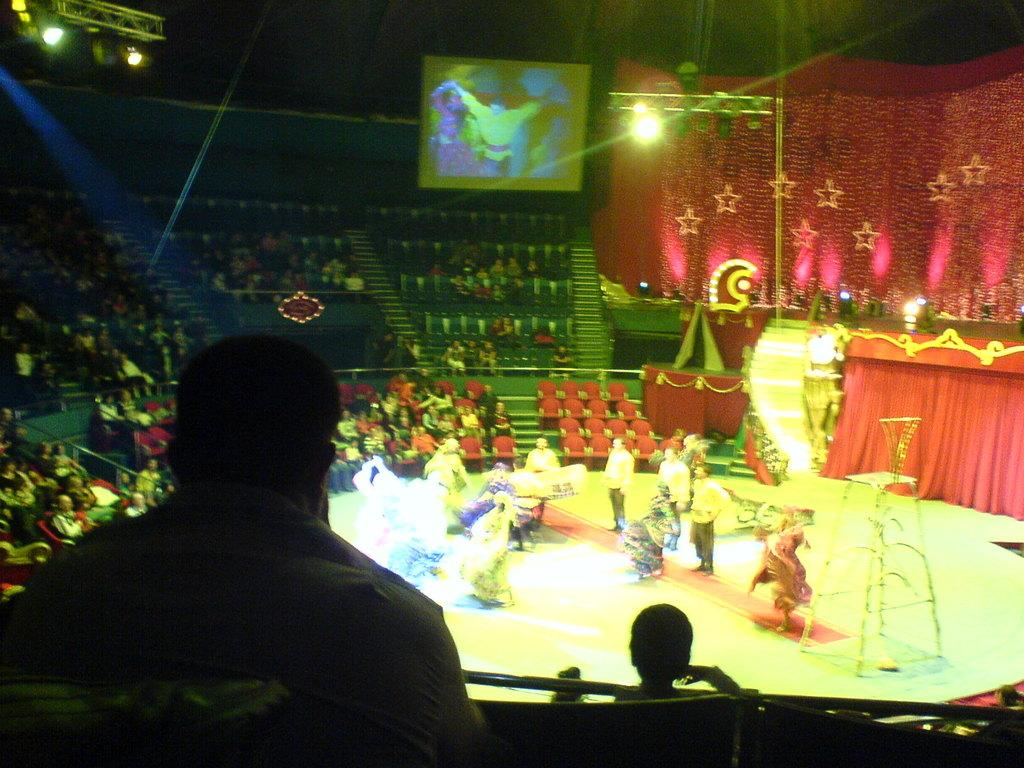How many people are in the image? There is a group of people in the image. What are some of the people in the image doing? Some people are sitting on chairs, while others are on stage. What can be seen in the background of the image? There is a screen, lights, and curtains in the image. What type of truck is parked next to the stage in the image? There is no truck present in the image; it only features a group of people, chairs, a stage, a screen, lights, and curtains. What toy is being used by the people on stage in the image? There is no toy visible in the image; the people on stage are not using any toys. 